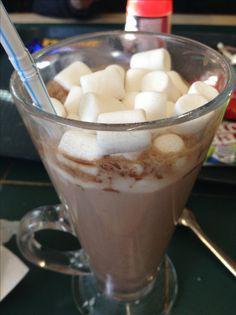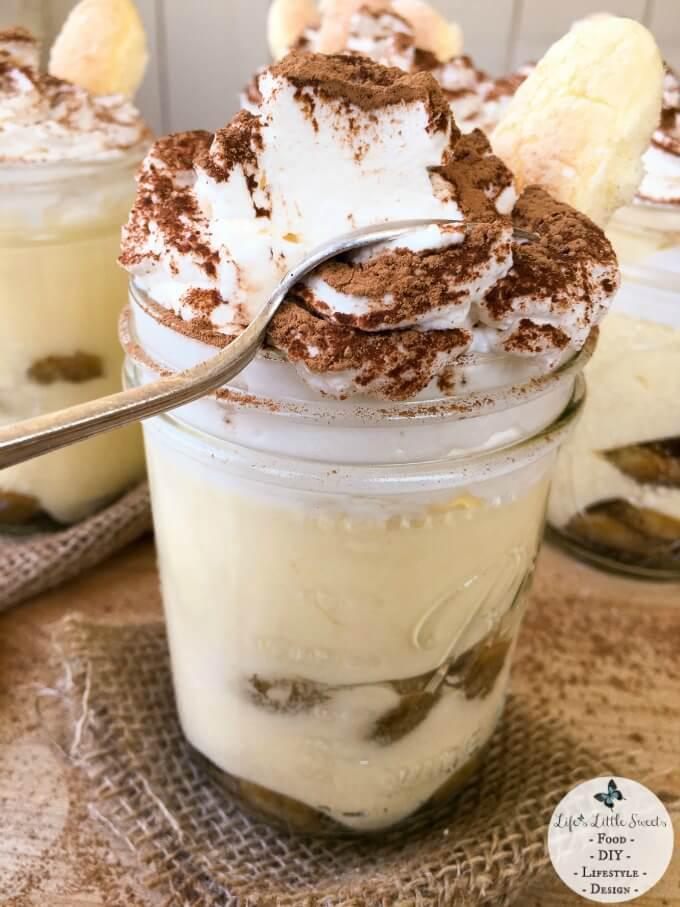The first image is the image on the left, the second image is the image on the right. Examine the images to the left and right. Is the description "In one image, two individual desserts have layers of strawberries and blueberries, and are topped with whipped cream." accurate? Answer yes or no. No. The first image is the image on the left, the second image is the image on the right. Considering the images on both sides, is "An image shows side-by-side desserts with blueberries around the rim." valid? Answer yes or no. No. 